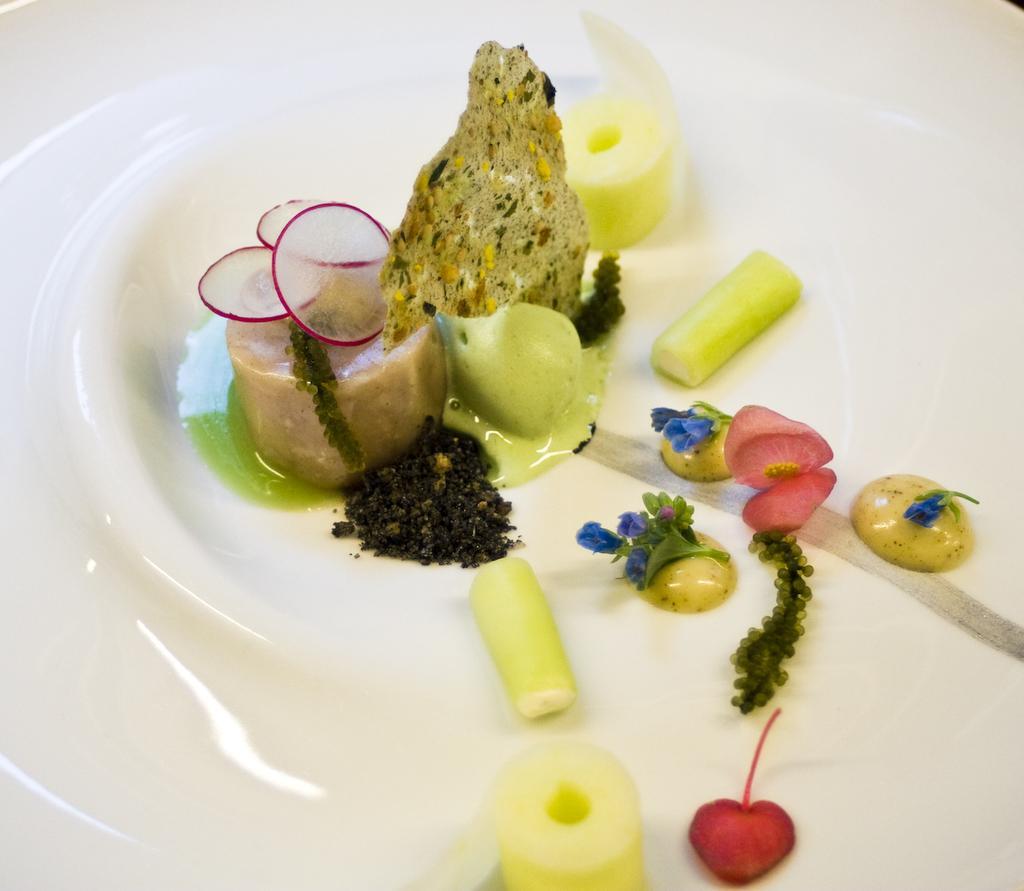In one or two sentences, can you explain what this image depicts? In the center of the image we can see food placed on the plate. 